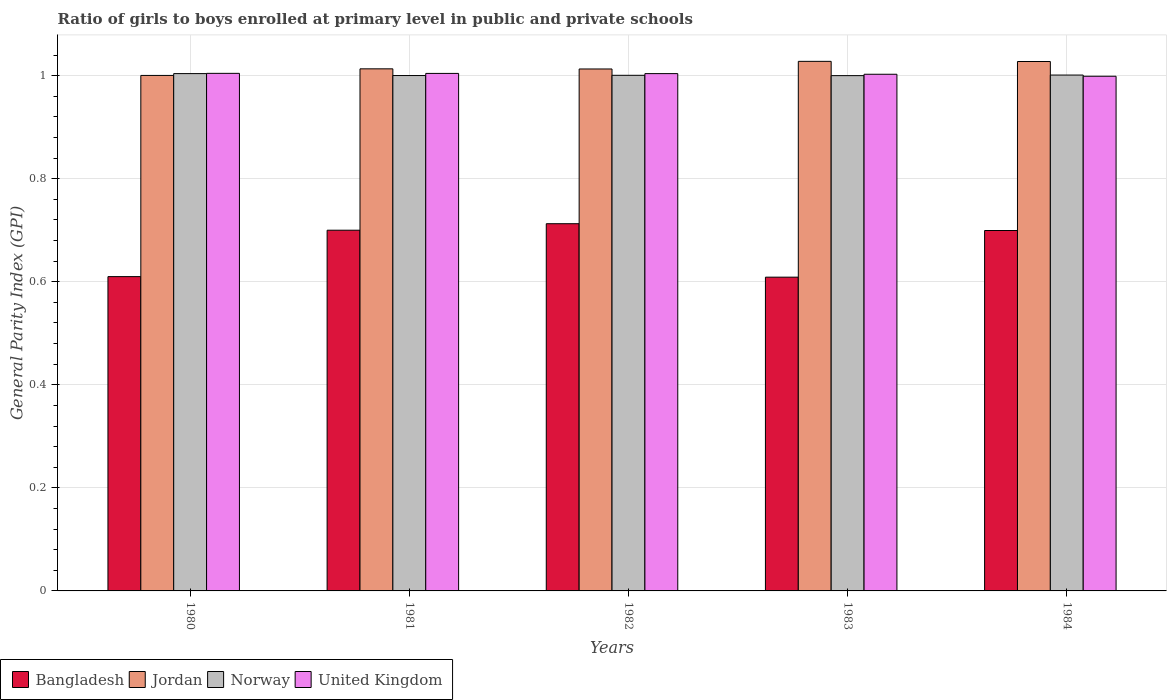How many different coloured bars are there?
Your response must be concise. 4. How many groups of bars are there?
Keep it short and to the point. 5. How many bars are there on the 3rd tick from the left?
Your response must be concise. 4. How many bars are there on the 1st tick from the right?
Your response must be concise. 4. In how many cases, is the number of bars for a given year not equal to the number of legend labels?
Provide a short and direct response. 0. What is the general parity index in Jordan in 1980?
Your answer should be very brief. 1. Across all years, what is the maximum general parity index in Norway?
Keep it short and to the point. 1. Across all years, what is the minimum general parity index in Bangladesh?
Your answer should be very brief. 0.61. What is the total general parity index in Bangladesh in the graph?
Your response must be concise. 3.33. What is the difference between the general parity index in Norway in 1980 and that in 1981?
Your answer should be very brief. 0. What is the difference between the general parity index in Norway in 1982 and the general parity index in Jordan in 1984?
Keep it short and to the point. -0.03. What is the average general parity index in Bangladesh per year?
Ensure brevity in your answer.  0.67. In the year 1984, what is the difference between the general parity index in Norway and general parity index in Jordan?
Your answer should be compact. -0.03. In how many years, is the general parity index in United Kingdom greater than 0.52?
Your answer should be compact. 5. What is the ratio of the general parity index in Bangladesh in 1983 to that in 1984?
Offer a terse response. 0.87. What is the difference between the highest and the second highest general parity index in Bangladesh?
Make the answer very short. 0.01. What is the difference between the highest and the lowest general parity index in United Kingdom?
Offer a very short reply. 0.01. Is the sum of the general parity index in Bangladesh in 1980 and 1981 greater than the maximum general parity index in Norway across all years?
Offer a very short reply. Yes. What does the 1st bar from the left in 1982 represents?
Offer a very short reply. Bangladesh. What does the 4th bar from the right in 1983 represents?
Your answer should be compact. Bangladesh. Is it the case that in every year, the sum of the general parity index in United Kingdom and general parity index in Bangladesh is greater than the general parity index in Norway?
Ensure brevity in your answer.  Yes. How many bars are there?
Offer a terse response. 20. Are all the bars in the graph horizontal?
Offer a terse response. No. Are the values on the major ticks of Y-axis written in scientific E-notation?
Ensure brevity in your answer.  No. Where does the legend appear in the graph?
Provide a short and direct response. Bottom left. How are the legend labels stacked?
Your answer should be compact. Horizontal. What is the title of the graph?
Offer a terse response. Ratio of girls to boys enrolled at primary level in public and private schools. Does "Guinea-Bissau" appear as one of the legend labels in the graph?
Make the answer very short. No. What is the label or title of the X-axis?
Offer a very short reply. Years. What is the label or title of the Y-axis?
Give a very brief answer. General Parity Index (GPI). What is the General Parity Index (GPI) in Bangladesh in 1980?
Offer a very short reply. 0.61. What is the General Parity Index (GPI) of Jordan in 1980?
Offer a very short reply. 1. What is the General Parity Index (GPI) in Norway in 1980?
Make the answer very short. 1. What is the General Parity Index (GPI) of United Kingdom in 1980?
Keep it short and to the point. 1. What is the General Parity Index (GPI) of Bangladesh in 1981?
Make the answer very short. 0.7. What is the General Parity Index (GPI) of Jordan in 1981?
Keep it short and to the point. 1.01. What is the General Parity Index (GPI) of Norway in 1981?
Your answer should be very brief. 1. What is the General Parity Index (GPI) in United Kingdom in 1981?
Provide a succinct answer. 1. What is the General Parity Index (GPI) in Bangladesh in 1982?
Provide a succinct answer. 0.71. What is the General Parity Index (GPI) of Jordan in 1982?
Your answer should be very brief. 1.01. What is the General Parity Index (GPI) of Norway in 1982?
Ensure brevity in your answer.  1. What is the General Parity Index (GPI) in United Kingdom in 1982?
Make the answer very short. 1. What is the General Parity Index (GPI) of Bangladesh in 1983?
Keep it short and to the point. 0.61. What is the General Parity Index (GPI) of Jordan in 1983?
Your answer should be very brief. 1.03. What is the General Parity Index (GPI) of Norway in 1983?
Provide a short and direct response. 1. What is the General Parity Index (GPI) of United Kingdom in 1983?
Give a very brief answer. 1. What is the General Parity Index (GPI) in Bangladesh in 1984?
Ensure brevity in your answer.  0.7. What is the General Parity Index (GPI) of Jordan in 1984?
Your answer should be very brief. 1.03. What is the General Parity Index (GPI) in Norway in 1984?
Provide a short and direct response. 1. What is the General Parity Index (GPI) in United Kingdom in 1984?
Give a very brief answer. 1. Across all years, what is the maximum General Parity Index (GPI) of Bangladesh?
Keep it short and to the point. 0.71. Across all years, what is the maximum General Parity Index (GPI) in Jordan?
Keep it short and to the point. 1.03. Across all years, what is the maximum General Parity Index (GPI) of Norway?
Give a very brief answer. 1. Across all years, what is the maximum General Parity Index (GPI) of United Kingdom?
Make the answer very short. 1. Across all years, what is the minimum General Parity Index (GPI) in Bangladesh?
Provide a succinct answer. 0.61. Across all years, what is the minimum General Parity Index (GPI) in Jordan?
Offer a very short reply. 1. Across all years, what is the minimum General Parity Index (GPI) in Norway?
Offer a terse response. 1. What is the total General Parity Index (GPI) of Bangladesh in the graph?
Keep it short and to the point. 3.33. What is the total General Parity Index (GPI) in Jordan in the graph?
Offer a terse response. 5.08. What is the total General Parity Index (GPI) in Norway in the graph?
Ensure brevity in your answer.  5.01. What is the total General Parity Index (GPI) of United Kingdom in the graph?
Ensure brevity in your answer.  5.01. What is the difference between the General Parity Index (GPI) in Bangladesh in 1980 and that in 1981?
Provide a short and direct response. -0.09. What is the difference between the General Parity Index (GPI) in Jordan in 1980 and that in 1981?
Give a very brief answer. -0.01. What is the difference between the General Parity Index (GPI) of Norway in 1980 and that in 1981?
Offer a very short reply. 0. What is the difference between the General Parity Index (GPI) of Bangladesh in 1980 and that in 1982?
Your response must be concise. -0.1. What is the difference between the General Parity Index (GPI) in Jordan in 1980 and that in 1982?
Make the answer very short. -0.01. What is the difference between the General Parity Index (GPI) in Norway in 1980 and that in 1982?
Offer a terse response. 0. What is the difference between the General Parity Index (GPI) in Jordan in 1980 and that in 1983?
Offer a terse response. -0.03. What is the difference between the General Parity Index (GPI) in Norway in 1980 and that in 1983?
Make the answer very short. 0. What is the difference between the General Parity Index (GPI) in United Kingdom in 1980 and that in 1983?
Provide a succinct answer. 0. What is the difference between the General Parity Index (GPI) of Bangladesh in 1980 and that in 1984?
Your answer should be very brief. -0.09. What is the difference between the General Parity Index (GPI) in Jordan in 1980 and that in 1984?
Your answer should be very brief. -0.03. What is the difference between the General Parity Index (GPI) in Norway in 1980 and that in 1984?
Keep it short and to the point. 0. What is the difference between the General Parity Index (GPI) in United Kingdom in 1980 and that in 1984?
Make the answer very short. 0.01. What is the difference between the General Parity Index (GPI) of Bangladesh in 1981 and that in 1982?
Make the answer very short. -0.01. What is the difference between the General Parity Index (GPI) of Norway in 1981 and that in 1982?
Your answer should be very brief. -0. What is the difference between the General Parity Index (GPI) in Bangladesh in 1981 and that in 1983?
Your response must be concise. 0.09. What is the difference between the General Parity Index (GPI) in Jordan in 1981 and that in 1983?
Your response must be concise. -0.01. What is the difference between the General Parity Index (GPI) in United Kingdom in 1981 and that in 1983?
Your answer should be very brief. 0. What is the difference between the General Parity Index (GPI) of Bangladesh in 1981 and that in 1984?
Provide a succinct answer. 0. What is the difference between the General Parity Index (GPI) in Jordan in 1981 and that in 1984?
Provide a succinct answer. -0.01. What is the difference between the General Parity Index (GPI) in Norway in 1981 and that in 1984?
Your response must be concise. -0. What is the difference between the General Parity Index (GPI) of United Kingdom in 1981 and that in 1984?
Keep it short and to the point. 0.01. What is the difference between the General Parity Index (GPI) in Bangladesh in 1982 and that in 1983?
Offer a terse response. 0.1. What is the difference between the General Parity Index (GPI) of Jordan in 1982 and that in 1983?
Your answer should be compact. -0.01. What is the difference between the General Parity Index (GPI) in Norway in 1982 and that in 1983?
Provide a short and direct response. 0. What is the difference between the General Parity Index (GPI) of United Kingdom in 1982 and that in 1983?
Make the answer very short. 0. What is the difference between the General Parity Index (GPI) of Bangladesh in 1982 and that in 1984?
Keep it short and to the point. 0.01. What is the difference between the General Parity Index (GPI) in Jordan in 1982 and that in 1984?
Offer a very short reply. -0.01. What is the difference between the General Parity Index (GPI) in Norway in 1982 and that in 1984?
Ensure brevity in your answer.  -0. What is the difference between the General Parity Index (GPI) in United Kingdom in 1982 and that in 1984?
Ensure brevity in your answer.  0.01. What is the difference between the General Parity Index (GPI) of Bangladesh in 1983 and that in 1984?
Provide a short and direct response. -0.09. What is the difference between the General Parity Index (GPI) in Norway in 1983 and that in 1984?
Your answer should be very brief. -0. What is the difference between the General Parity Index (GPI) of United Kingdom in 1983 and that in 1984?
Your answer should be very brief. 0. What is the difference between the General Parity Index (GPI) of Bangladesh in 1980 and the General Parity Index (GPI) of Jordan in 1981?
Your response must be concise. -0.4. What is the difference between the General Parity Index (GPI) in Bangladesh in 1980 and the General Parity Index (GPI) in Norway in 1981?
Offer a very short reply. -0.39. What is the difference between the General Parity Index (GPI) in Bangladesh in 1980 and the General Parity Index (GPI) in United Kingdom in 1981?
Ensure brevity in your answer.  -0.39. What is the difference between the General Parity Index (GPI) in Jordan in 1980 and the General Parity Index (GPI) in United Kingdom in 1981?
Provide a succinct answer. -0. What is the difference between the General Parity Index (GPI) of Norway in 1980 and the General Parity Index (GPI) of United Kingdom in 1981?
Provide a short and direct response. -0. What is the difference between the General Parity Index (GPI) in Bangladesh in 1980 and the General Parity Index (GPI) in Jordan in 1982?
Keep it short and to the point. -0.4. What is the difference between the General Parity Index (GPI) of Bangladesh in 1980 and the General Parity Index (GPI) of Norway in 1982?
Give a very brief answer. -0.39. What is the difference between the General Parity Index (GPI) in Bangladesh in 1980 and the General Parity Index (GPI) in United Kingdom in 1982?
Your answer should be compact. -0.39. What is the difference between the General Parity Index (GPI) of Jordan in 1980 and the General Parity Index (GPI) of Norway in 1982?
Ensure brevity in your answer.  -0. What is the difference between the General Parity Index (GPI) of Jordan in 1980 and the General Parity Index (GPI) of United Kingdom in 1982?
Ensure brevity in your answer.  -0. What is the difference between the General Parity Index (GPI) in Bangladesh in 1980 and the General Parity Index (GPI) in Jordan in 1983?
Provide a succinct answer. -0.42. What is the difference between the General Parity Index (GPI) in Bangladesh in 1980 and the General Parity Index (GPI) in Norway in 1983?
Ensure brevity in your answer.  -0.39. What is the difference between the General Parity Index (GPI) of Bangladesh in 1980 and the General Parity Index (GPI) of United Kingdom in 1983?
Give a very brief answer. -0.39. What is the difference between the General Parity Index (GPI) of Jordan in 1980 and the General Parity Index (GPI) of Norway in 1983?
Offer a terse response. 0. What is the difference between the General Parity Index (GPI) of Jordan in 1980 and the General Parity Index (GPI) of United Kingdom in 1983?
Provide a short and direct response. -0. What is the difference between the General Parity Index (GPI) in Norway in 1980 and the General Parity Index (GPI) in United Kingdom in 1983?
Your answer should be very brief. 0. What is the difference between the General Parity Index (GPI) of Bangladesh in 1980 and the General Parity Index (GPI) of Jordan in 1984?
Provide a succinct answer. -0.42. What is the difference between the General Parity Index (GPI) of Bangladesh in 1980 and the General Parity Index (GPI) of Norway in 1984?
Offer a very short reply. -0.39. What is the difference between the General Parity Index (GPI) of Bangladesh in 1980 and the General Parity Index (GPI) of United Kingdom in 1984?
Offer a terse response. -0.39. What is the difference between the General Parity Index (GPI) in Jordan in 1980 and the General Parity Index (GPI) in Norway in 1984?
Provide a succinct answer. -0. What is the difference between the General Parity Index (GPI) in Jordan in 1980 and the General Parity Index (GPI) in United Kingdom in 1984?
Make the answer very short. 0. What is the difference between the General Parity Index (GPI) of Norway in 1980 and the General Parity Index (GPI) of United Kingdom in 1984?
Your answer should be compact. 0.01. What is the difference between the General Parity Index (GPI) of Bangladesh in 1981 and the General Parity Index (GPI) of Jordan in 1982?
Make the answer very short. -0.31. What is the difference between the General Parity Index (GPI) of Bangladesh in 1981 and the General Parity Index (GPI) of Norway in 1982?
Give a very brief answer. -0.3. What is the difference between the General Parity Index (GPI) of Bangladesh in 1981 and the General Parity Index (GPI) of United Kingdom in 1982?
Offer a terse response. -0.3. What is the difference between the General Parity Index (GPI) in Jordan in 1981 and the General Parity Index (GPI) in Norway in 1982?
Offer a very short reply. 0.01. What is the difference between the General Parity Index (GPI) of Jordan in 1981 and the General Parity Index (GPI) of United Kingdom in 1982?
Offer a very short reply. 0.01. What is the difference between the General Parity Index (GPI) of Norway in 1981 and the General Parity Index (GPI) of United Kingdom in 1982?
Offer a very short reply. -0. What is the difference between the General Parity Index (GPI) of Bangladesh in 1981 and the General Parity Index (GPI) of Jordan in 1983?
Make the answer very short. -0.33. What is the difference between the General Parity Index (GPI) in Bangladesh in 1981 and the General Parity Index (GPI) in Norway in 1983?
Keep it short and to the point. -0.3. What is the difference between the General Parity Index (GPI) of Bangladesh in 1981 and the General Parity Index (GPI) of United Kingdom in 1983?
Provide a short and direct response. -0.3. What is the difference between the General Parity Index (GPI) of Jordan in 1981 and the General Parity Index (GPI) of Norway in 1983?
Your answer should be compact. 0.01. What is the difference between the General Parity Index (GPI) of Jordan in 1981 and the General Parity Index (GPI) of United Kingdom in 1983?
Your answer should be compact. 0.01. What is the difference between the General Parity Index (GPI) of Norway in 1981 and the General Parity Index (GPI) of United Kingdom in 1983?
Your answer should be very brief. -0. What is the difference between the General Parity Index (GPI) of Bangladesh in 1981 and the General Parity Index (GPI) of Jordan in 1984?
Make the answer very short. -0.33. What is the difference between the General Parity Index (GPI) in Bangladesh in 1981 and the General Parity Index (GPI) in Norway in 1984?
Your answer should be very brief. -0.3. What is the difference between the General Parity Index (GPI) in Bangladesh in 1981 and the General Parity Index (GPI) in United Kingdom in 1984?
Provide a succinct answer. -0.3. What is the difference between the General Parity Index (GPI) of Jordan in 1981 and the General Parity Index (GPI) of Norway in 1984?
Your answer should be compact. 0.01. What is the difference between the General Parity Index (GPI) of Jordan in 1981 and the General Parity Index (GPI) of United Kingdom in 1984?
Provide a succinct answer. 0.01. What is the difference between the General Parity Index (GPI) of Norway in 1981 and the General Parity Index (GPI) of United Kingdom in 1984?
Your answer should be compact. 0. What is the difference between the General Parity Index (GPI) in Bangladesh in 1982 and the General Parity Index (GPI) in Jordan in 1983?
Provide a succinct answer. -0.32. What is the difference between the General Parity Index (GPI) of Bangladesh in 1982 and the General Parity Index (GPI) of Norway in 1983?
Provide a short and direct response. -0.29. What is the difference between the General Parity Index (GPI) in Bangladesh in 1982 and the General Parity Index (GPI) in United Kingdom in 1983?
Provide a succinct answer. -0.29. What is the difference between the General Parity Index (GPI) of Jordan in 1982 and the General Parity Index (GPI) of Norway in 1983?
Your response must be concise. 0.01. What is the difference between the General Parity Index (GPI) of Jordan in 1982 and the General Parity Index (GPI) of United Kingdom in 1983?
Keep it short and to the point. 0.01. What is the difference between the General Parity Index (GPI) in Norway in 1982 and the General Parity Index (GPI) in United Kingdom in 1983?
Your response must be concise. -0. What is the difference between the General Parity Index (GPI) of Bangladesh in 1982 and the General Parity Index (GPI) of Jordan in 1984?
Give a very brief answer. -0.31. What is the difference between the General Parity Index (GPI) in Bangladesh in 1982 and the General Parity Index (GPI) in Norway in 1984?
Your response must be concise. -0.29. What is the difference between the General Parity Index (GPI) of Bangladesh in 1982 and the General Parity Index (GPI) of United Kingdom in 1984?
Your response must be concise. -0.29. What is the difference between the General Parity Index (GPI) in Jordan in 1982 and the General Parity Index (GPI) in Norway in 1984?
Provide a succinct answer. 0.01. What is the difference between the General Parity Index (GPI) of Jordan in 1982 and the General Parity Index (GPI) of United Kingdom in 1984?
Ensure brevity in your answer.  0.01. What is the difference between the General Parity Index (GPI) in Norway in 1982 and the General Parity Index (GPI) in United Kingdom in 1984?
Your answer should be very brief. 0. What is the difference between the General Parity Index (GPI) in Bangladesh in 1983 and the General Parity Index (GPI) in Jordan in 1984?
Offer a very short reply. -0.42. What is the difference between the General Parity Index (GPI) of Bangladesh in 1983 and the General Parity Index (GPI) of Norway in 1984?
Keep it short and to the point. -0.39. What is the difference between the General Parity Index (GPI) of Bangladesh in 1983 and the General Parity Index (GPI) of United Kingdom in 1984?
Offer a very short reply. -0.39. What is the difference between the General Parity Index (GPI) in Jordan in 1983 and the General Parity Index (GPI) in Norway in 1984?
Give a very brief answer. 0.03. What is the difference between the General Parity Index (GPI) in Jordan in 1983 and the General Parity Index (GPI) in United Kingdom in 1984?
Make the answer very short. 0.03. What is the difference between the General Parity Index (GPI) of Norway in 1983 and the General Parity Index (GPI) of United Kingdom in 1984?
Provide a short and direct response. 0. What is the average General Parity Index (GPI) in Bangladesh per year?
Your response must be concise. 0.67. What is the average General Parity Index (GPI) in Jordan per year?
Your answer should be compact. 1.02. What is the average General Parity Index (GPI) of Norway per year?
Provide a succinct answer. 1. What is the average General Parity Index (GPI) of United Kingdom per year?
Give a very brief answer. 1. In the year 1980, what is the difference between the General Parity Index (GPI) in Bangladesh and General Parity Index (GPI) in Jordan?
Make the answer very short. -0.39. In the year 1980, what is the difference between the General Parity Index (GPI) of Bangladesh and General Parity Index (GPI) of Norway?
Offer a terse response. -0.39. In the year 1980, what is the difference between the General Parity Index (GPI) in Bangladesh and General Parity Index (GPI) in United Kingdom?
Keep it short and to the point. -0.39. In the year 1980, what is the difference between the General Parity Index (GPI) in Jordan and General Parity Index (GPI) in Norway?
Ensure brevity in your answer.  -0. In the year 1980, what is the difference between the General Parity Index (GPI) in Jordan and General Parity Index (GPI) in United Kingdom?
Ensure brevity in your answer.  -0. In the year 1980, what is the difference between the General Parity Index (GPI) of Norway and General Parity Index (GPI) of United Kingdom?
Provide a short and direct response. -0. In the year 1981, what is the difference between the General Parity Index (GPI) in Bangladesh and General Parity Index (GPI) in Jordan?
Provide a short and direct response. -0.31. In the year 1981, what is the difference between the General Parity Index (GPI) of Bangladesh and General Parity Index (GPI) of Norway?
Ensure brevity in your answer.  -0.3. In the year 1981, what is the difference between the General Parity Index (GPI) in Bangladesh and General Parity Index (GPI) in United Kingdom?
Your answer should be very brief. -0.3. In the year 1981, what is the difference between the General Parity Index (GPI) of Jordan and General Parity Index (GPI) of Norway?
Provide a succinct answer. 0.01. In the year 1981, what is the difference between the General Parity Index (GPI) in Jordan and General Parity Index (GPI) in United Kingdom?
Provide a succinct answer. 0.01. In the year 1981, what is the difference between the General Parity Index (GPI) of Norway and General Parity Index (GPI) of United Kingdom?
Offer a terse response. -0. In the year 1982, what is the difference between the General Parity Index (GPI) of Bangladesh and General Parity Index (GPI) of Jordan?
Provide a succinct answer. -0.3. In the year 1982, what is the difference between the General Parity Index (GPI) in Bangladesh and General Parity Index (GPI) in Norway?
Offer a terse response. -0.29. In the year 1982, what is the difference between the General Parity Index (GPI) in Bangladesh and General Parity Index (GPI) in United Kingdom?
Make the answer very short. -0.29. In the year 1982, what is the difference between the General Parity Index (GPI) of Jordan and General Parity Index (GPI) of Norway?
Your answer should be compact. 0.01. In the year 1982, what is the difference between the General Parity Index (GPI) of Jordan and General Parity Index (GPI) of United Kingdom?
Offer a very short reply. 0.01. In the year 1982, what is the difference between the General Parity Index (GPI) in Norway and General Parity Index (GPI) in United Kingdom?
Keep it short and to the point. -0. In the year 1983, what is the difference between the General Parity Index (GPI) of Bangladesh and General Parity Index (GPI) of Jordan?
Your answer should be very brief. -0.42. In the year 1983, what is the difference between the General Parity Index (GPI) of Bangladesh and General Parity Index (GPI) of Norway?
Your response must be concise. -0.39. In the year 1983, what is the difference between the General Parity Index (GPI) of Bangladesh and General Parity Index (GPI) of United Kingdom?
Your answer should be very brief. -0.39. In the year 1983, what is the difference between the General Parity Index (GPI) of Jordan and General Parity Index (GPI) of Norway?
Provide a succinct answer. 0.03. In the year 1983, what is the difference between the General Parity Index (GPI) in Jordan and General Parity Index (GPI) in United Kingdom?
Your answer should be very brief. 0.03. In the year 1983, what is the difference between the General Parity Index (GPI) of Norway and General Parity Index (GPI) of United Kingdom?
Keep it short and to the point. -0. In the year 1984, what is the difference between the General Parity Index (GPI) in Bangladesh and General Parity Index (GPI) in Jordan?
Give a very brief answer. -0.33. In the year 1984, what is the difference between the General Parity Index (GPI) in Bangladesh and General Parity Index (GPI) in Norway?
Your answer should be very brief. -0.3. In the year 1984, what is the difference between the General Parity Index (GPI) of Bangladesh and General Parity Index (GPI) of United Kingdom?
Offer a very short reply. -0.3. In the year 1984, what is the difference between the General Parity Index (GPI) of Jordan and General Parity Index (GPI) of Norway?
Your answer should be compact. 0.03. In the year 1984, what is the difference between the General Parity Index (GPI) in Jordan and General Parity Index (GPI) in United Kingdom?
Give a very brief answer. 0.03. In the year 1984, what is the difference between the General Parity Index (GPI) in Norway and General Parity Index (GPI) in United Kingdom?
Keep it short and to the point. 0. What is the ratio of the General Parity Index (GPI) in Bangladesh in 1980 to that in 1981?
Your answer should be very brief. 0.87. What is the ratio of the General Parity Index (GPI) of Jordan in 1980 to that in 1981?
Your response must be concise. 0.99. What is the ratio of the General Parity Index (GPI) of Norway in 1980 to that in 1981?
Your answer should be very brief. 1. What is the ratio of the General Parity Index (GPI) in Bangladesh in 1980 to that in 1982?
Ensure brevity in your answer.  0.86. What is the ratio of the General Parity Index (GPI) of Jordan in 1980 to that in 1982?
Provide a short and direct response. 0.99. What is the ratio of the General Parity Index (GPI) of Norway in 1980 to that in 1982?
Provide a short and direct response. 1. What is the ratio of the General Parity Index (GPI) in United Kingdom in 1980 to that in 1982?
Provide a short and direct response. 1. What is the ratio of the General Parity Index (GPI) of Bangladesh in 1980 to that in 1983?
Provide a short and direct response. 1. What is the ratio of the General Parity Index (GPI) of Jordan in 1980 to that in 1983?
Make the answer very short. 0.97. What is the ratio of the General Parity Index (GPI) in Norway in 1980 to that in 1983?
Provide a succinct answer. 1. What is the ratio of the General Parity Index (GPI) of Bangladesh in 1980 to that in 1984?
Your answer should be very brief. 0.87. What is the ratio of the General Parity Index (GPI) in Jordan in 1980 to that in 1984?
Ensure brevity in your answer.  0.97. What is the ratio of the General Parity Index (GPI) in Norway in 1980 to that in 1984?
Offer a terse response. 1. What is the ratio of the General Parity Index (GPI) of United Kingdom in 1980 to that in 1984?
Your response must be concise. 1.01. What is the ratio of the General Parity Index (GPI) in Bangladesh in 1981 to that in 1982?
Provide a short and direct response. 0.98. What is the ratio of the General Parity Index (GPI) of Jordan in 1981 to that in 1982?
Offer a very short reply. 1. What is the ratio of the General Parity Index (GPI) in Norway in 1981 to that in 1982?
Ensure brevity in your answer.  1. What is the ratio of the General Parity Index (GPI) of United Kingdom in 1981 to that in 1982?
Give a very brief answer. 1. What is the ratio of the General Parity Index (GPI) in Bangladesh in 1981 to that in 1983?
Your answer should be very brief. 1.15. What is the ratio of the General Parity Index (GPI) in Jordan in 1981 to that in 1983?
Provide a succinct answer. 0.99. What is the ratio of the General Parity Index (GPI) of Norway in 1981 to that in 1983?
Your answer should be very brief. 1. What is the ratio of the General Parity Index (GPI) of United Kingdom in 1981 to that in 1983?
Provide a succinct answer. 1. What is the ratio of the General Parity Index (GPI) in Bangladesh in 1981 to that in 1984?
Keep it short and to the point. 1. What is the ratio of the General Parity Index (GPI) of Jordan in 1981 to that in 1984?
Provide a short and direct response. 0.99. What is the ratio of the General Parity Index (GPI) of Norway in 1981 to that in 1984?
Keep it short and to the point. 1. What is the ratio of the General Parity Index (GPI) in Bangladesh in 1982 to that in 1983?
Your response must be concise. 1.17. What is the ratio of the General Parity Index (GPI) in Jordan in 1982 to that in 1983?
Your response must be concise. 0.99. What is the ratio of the General Parity Index (GPI) of United Kingdom in 1982 to that in 1983?
Your response must be concise. 1. What is the ratio of the General Parity Index (GPI) of Bangladesh in 1982 to that in 1984?
Make the answer very short. 1.02. What is the ratio of the General Parity Index (GPI) of Jordan in 1982 to that in 1984?
Your answer should be compact. 0.99. What is the ratio of the General Parity Index (GPI) of Norway in 1982 to that in 1984?
Keep it short and to the point. 1. What is the ratio of the General Parity Index (GPI) of Bangladesh in 1983 to that in 1984?
Offer a very short reply. 0.87. What is the ratio of the General Parity Index (GPI) in Jordan in 1983 to that in 1984?
Your answer should be compact. 1. What is the ratio of the General Parity Index (GPI) of Norway in 1983 to that in 1984?
Provide a short and direct response. 1. What is the ratio of the General Parity Index (GPI) of United Kingdom in 1983 to that in 1984?
Give a very brief answer. 1. What is the difference between the highest and the second highest General Parity Index (GPI) of Bangladesh?
Your answer should be very brief. 0.01. What is the difference between the highest and the second highest General Parity Index (GPI) in Jordan?
Make the answer very short. 0. What is the difference between the highest and the second highest General Parity Index (GPI) in Norway?
Provide a short and direct response. 0. What is the difference between the highest and the lowest General Parity Index (GPI) of Bangladesh?
Offer a terse response. 0.1. What is the difference between the highest and the lowest General Parity Index (GPI) in Jordan?
Your answer should be compact. 0.03. What is the difference between the highest and the lowest General Parity Index (GPI) of Norway?
Provide a short and direct response. 0. What is the difference between the highest and the lowest General Parity Index (GPI) of United Kingdom?
Make the answer very short. 0.01. 